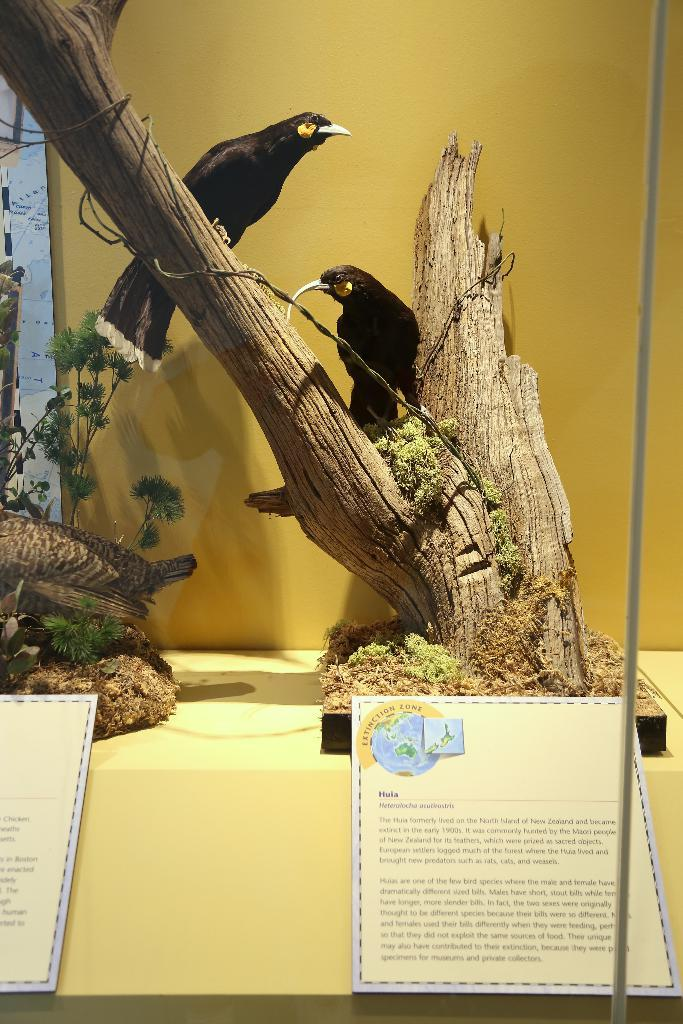What are the birds standing on in the image? The birds are standing on wood in the image. What can be seen on the yellow table in the image? There are posters on the yellow table in the image. What type of vegetation is visible on the left side of the image? There are plants visible on the left side of the image. What is the governor doing in the image? There is no governor present in the image. 